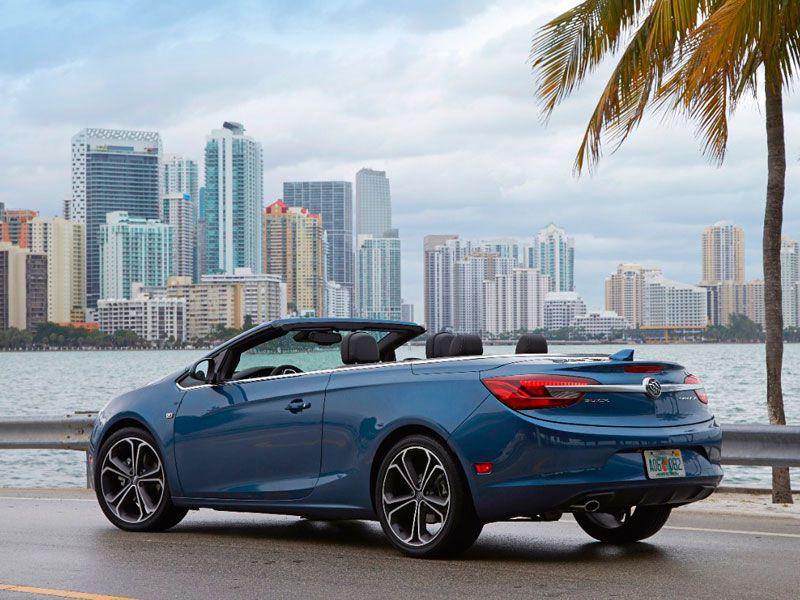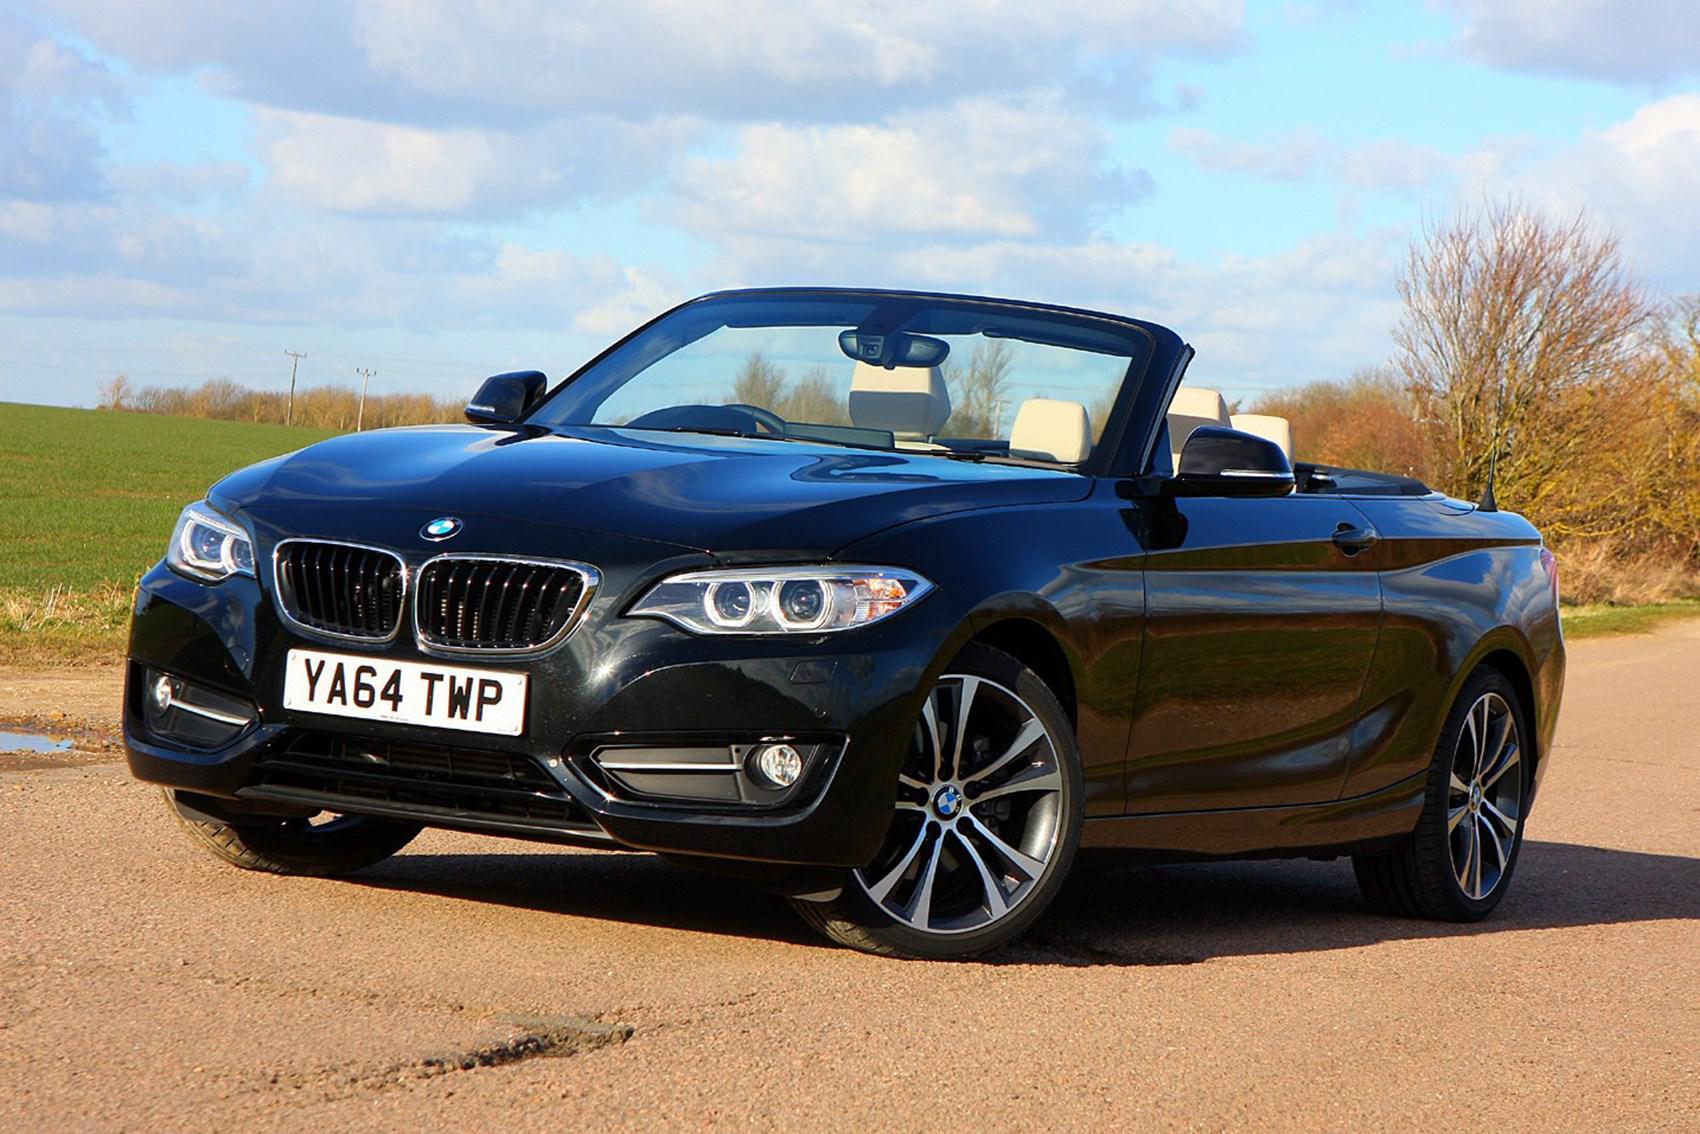The first image is the image on the left, the second image is the image on the right. Analyze the images presented: Is the assertion "There is a red convertible car in one image" valid? Answer yes or no. No. The first image is the image on the left, the second image is the image on the right. Given the left and right images, does the statement "There is a red convertible in one image." hold true? Answer yes or no. No. 